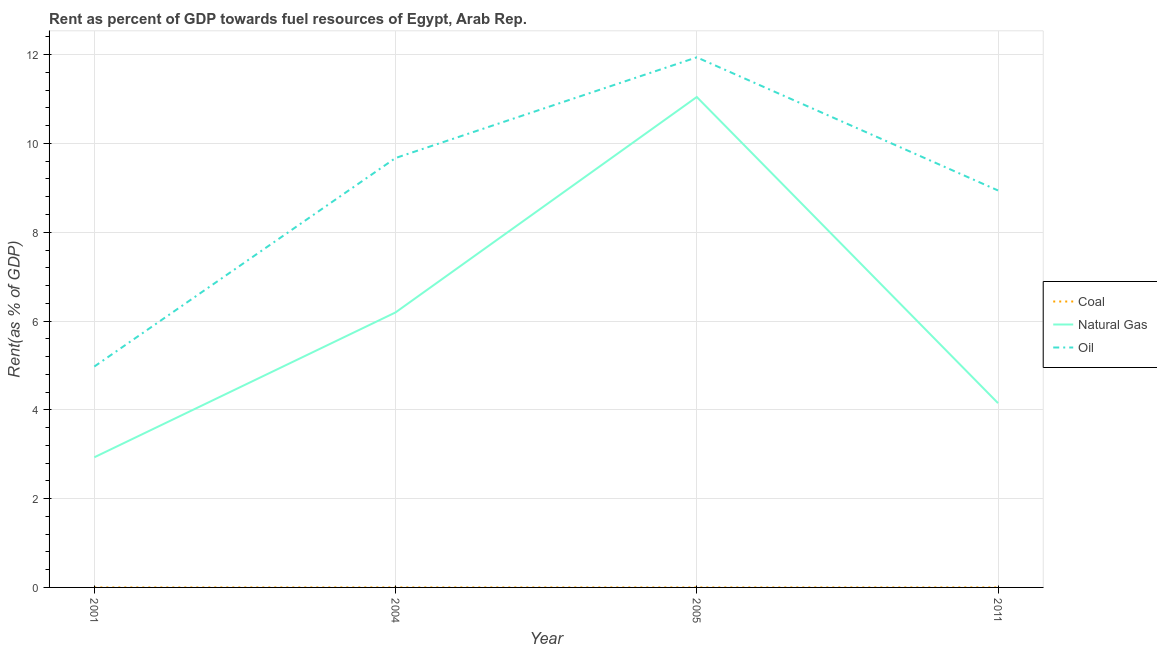How many different coloured lines are there?
Keep it short and to the point. 3. Does the line corresponding to rent towards coal intersect with the line corresponding to rent towards natural gas?
Your answer should be compact. No. Is the number of lines equal to the number of legend labels?
Make the answer very short. Yes. What is the rent towards oil in 2011?
Keep it short and to the point. 8.94. Across all years, what is the maximum rent towards oil?
Your response must be concise. 11.94. Across all years, what is the minimum rent towards coal?
Your answer should be compact. 1.02739128441411e-6. What is the total rent towards oil in the graph?
Offer a very short reply. 35.53. What is the difference between the rent towards natural gas in 2004 and that in 2005?
Make the answer very short. -4.85. What is the difference between the rent towards natural gas in 2005 and the rent towards coal in 2001?
Keep it short and to the point. 11.05. What is the average rent towards coal per year?
Ensure brevity in your answer.  0. In the year 2011, what is the difference between the rent towards natural gas and rent towards coal?
Your answer should be compact. 4.15. In how many years, is the rent towards natural gas greater than 2.8 %?
Make the answer very short. 4. What is the ratio of the rent towards natural gas in 2001 to that in 2005?
Your answer should be very brief. 0.27. Is the rent towards coal in 2004 less than that in 2005?
Your response must be concise. No. What is the difference between the highest and the second highest rent towards natural gas?
Offer a very short reply. 4.85. What is the difference between the highest and the lowest rent towards natural gas?
Provide a succinct answer. 8.12. Is the sum of the rent towards coal in 2001 and 2005 greater than the maximum rent towards oil across all years?
Provide a succinct answer. No. Is it the case that in every year, the sum of the rent towards coal and rent towards natural gas is greater than the rent towards oil?
Make the answer very short. No. Does the graph contain any zero values?
Ensure brevity in your answer.  No. Does the graph contain grids?
Offer a terse response. Yes. Where does the legend appear in the graph?
Give a very brief answer. Center right. How are the legend labels stacked?
Give a very brief answer. Vertical. What is the title of the graph?
Ensure brevity in your answer.  Rent as percent of GDP towards fuel resources of Egypt, Arab Rep. What is the label or title of the Y-axis?
Ensure brevity in your answer.  Rent(as % of GDP). What is the Rent(as % of GDP) of Coal in 2001?
Give a very brief answer. 1.02739128441411e-6. What is the Rent(as % of GDP) in Natural Gas in 2001?
Keep it short and to the point. 2.93. What is the Rent(as % of GDP) in Oil in 2001?
Give a very brief answer. 4.98. What is the Rent(as % of GDP) in Coal in 2004?
Give a very brief answer. 0. What is the Rent(as % of GDP) in Natural Gas in 2004?
Keep it short and to the point. 6.19. What is the Rent(as % of GDP) in Oil in 2004?
Offer a very short reply. 9.67. What is the Rent(as % of GDP) in Coal in 2005?
Ensure brevity in your answer.  0. What is the Rent(as % of GDP) of Natural Gas in 2005?
Make the answer very short. 11.05. What is the Rent(as % of GDP) of Oil in 2005?
Offer a terse response. 11.94. What is the Rent(as % of GDP) of Coal in 2011?
Provide a short and direct response. 0. What is the Rent(as % of GDP) of Natural Gas in 2011?
Offer a terse response. 4.15. What is the Rent(as % of GDP) in Oil in 2011?
Give a very brief answer. 8.94. Across all years, what is the maximum Rent(as % of GDP) of Coal?
Make the answer very short. 0. Across all years, what is the maximum Rent(as % of GDP) in Natural Gas?
Your answer should be compact. 11.05. Across all years, what is the maximum Rent(as % of GDP) of Oil?
Your response must be concise. 11.94. Across all years, what is the minimum Rent(as % of GDP) in Coal?
Provide a succinct answer. 1.02739128441411e-6. Across all years, what is the minimum Rent(as % of GDP) of Natural Gas?
Your answer should be very brief. 2.93. Across all years, what is the minimum Rent(as % of GDP) in Oil?
Offer a very short reply. 4.98. What is the total Rent(as % of GDP) in Coal in the graph?
Your answer should be compact. 0. What is the total Rent(as % of GDP) in Natural Gas in the graph?
Provide a succinct answer. 24.32. What is the total Rent(as % of GDP) of Oil in the graph?
Give a very brief answer. 35.53. What is the difference between the Rent(as % of GDP) of Coal in 2001 and that in 2004?
Your answer should be compact. -0. What is the difference between the Rent(as % of GDP) in Natural Gas in 2001 and that in 2004?
Your answer should be very brief. -3.26. What is the difference between the Rent(as % of GDP) in Oil in 2001 and that in 2004?
Your answer should be compact. -4.7. What is the difference between the Rent(as % of GDP) in Coal in 2001 and that in 2005?
Your response must be concise. -0. What is the difference between the Rent(as % of GDP) of Natural Gas in 2001 and that in 2005?
Ensure brevity in your answer.  -8.12. What is the difference between the Rent(as % of GDP) of Oil in 2001 and that in 2005?
Provide a succinct answer. -6.96. What is the difference between the Rent(as % of GDP) in Coal in 2001 and that in 2011?
Provide a short and direct response. -0. What is the difference between the Rent(as % of GDP) of Natural Gas in 2001 and that in 2011?
Your answer should be compact. -1.22. What is the difference between the Rent(as % of GDP) of Oil in 2001 and that in 2011?
Your answer should be compact. -3.97. What is the difference between the Rent(as % of GDP) of Coal in 2004 and that in 2005?
Your response must be concise. 0. What is the difference between the Rent(as % of GDP) in Natural Gas in 2004 and that in 2005?
Provide a succinct answer. -4.85. What is the difference between the Rent(as % of GDP) of Oil in 2004 and that in 2005?
Make the answer very short. -2.27. What is the difference between the Rent(as % of GDP) in Natural Gas in 2004 and that in 2011?
Offer a very short reply. 2.04. What is the difference between the Rent(as % of GDP) in Oil in 2004 and that in 2011?
Offer a very short reply. 0.73. What is the difference between the Rent(as % of GDP) in Coal in 2005 and that in 2011?
Your response must be concise. -0. What is the difference between the Rent(as % of GDP) in Natural Gas in 2005 and that in 2011?
Offer a terse response. 6.9. What is the difference between the Rent(as % of GDP) of Oil in 2005 and that in 2011?
Keep it short and to the point. 3. What is the difference between the Rent(as % of GDP) of Coal in 2001 and the Rent(as % of GDP) of Natural Gas in 2004?
Provide a short and direct response. -6.19. What is the difference between the Rent(as % of GDP) of Coal in 2001 and the Rent(as % of GDP) of Oil in 2004?
Ensure brevity in your answer.  -9.67. What is the difference between the Rent(as % of GDP) in Natural Gas in 2001 and the Rent(as % of GDP) in Oil in 2004?
Keep it short and to the point. -6.74. What is the difference between the Rent(as % of GDP) in Coal in 2001 and the Rent(as % of GDP) in Natural Gas in 2005?
Your answer should be very brief. -11.05. What is the difference between the Rent(as % of GDP) of Coal in 2001 and the Rent(as % of GDP) of Oil in 2005?
Your answer should be very brief. -11.94. What is the difference between the Rent(as % of GDP) in Natural Gas in 2001 and the Rent(as % of GDP) in Oil in 2005?
Your answer should be very brief. -9.01. What is the difference between the Rent(as % of GDP) of Coal in 2001 and the Rent(as % of GDP) of Natural Gas in 2011?
Ensure brevity in your answer.  -4.15. What is the difference between the Rent(as % of GDP) of Coal in 2001 and the Rent(as % of GDP) of Oil in 2011?
Your response must be concise. -8.94. What is the difference between the Rent(as % of GDP) in Natural Gas in 2001 and the Rent(as % of GDP) in Oil in 2011?
Offer a very short reply. -6.01. What is the difference between the Rent(as % of GDP) of Coal in 2004 and the Rent(as % of GDP) of Natural Gas in 2005?
Keep it short and to the point. -11.05. What is the difference between the Rent(as % of GDP) in Coal in 2004 and the Rent(as % of GDP) in Oil in 2005?
Offer a terse response. -11.94. What is the difference between the Rent(as % of GDP) in Natural Gas in 2004 and the Rent(as % of GDP) in Oil in 2005?
Keep it short and to the point. -5.75. What is the difference between the Rent(as % of GDP) of Coal in 2004 and the Rent(as % of GDP) of Natural Gas in 2011?
Your answer should be compact. -4.15. What is the difference between the Rent(as % of GDP) of Coal in 2004 and the Rent(as % of GDP) of Oil in 2011?
Offer a terse response. -8.94. What is the difference between the Rent(as % of GDP) in Natural Gas in 2004 and the Rent(as % of GDP) in Oil in 2011?
Your answer should be compact. -2.75. What is the difference between the Rent(as % of GDP) of Coal in 2005 and the Rent(as % of GDP) of Natural Gas in 2011?
Your response must be concise. -4.15. What is the difference between the Rent(as % of GDP) of Coal in 2005 and the Rent(as % of GDP) of Oil in 2011?
Ensure brevity in your answer.  -8.94. What is the difference between the Rent(as % of GDP) in Natural Gas in 2005 and the Rent(as % of GDP) in Oil in 2011?
Keep it short and to the point. 2.11. What is the average Rent(as % of GDP) of Natural Gas per year?
Offer a terse response. 6.08. What is the average Rent(as % of GDP) in Oil per year?
Give a very brief answer. 8.88. In the year 2001, what is the difference between the Rent(as % of GDP) in Coal and Rent(as % of GDP) in Natural Gas?
Offer a terse response. -2.93. In the year 2001, what is the difference between the Rent(as % of GDP) of Coal and Rent(as % of GDP) of Oil?
Your answer should be compact. -4.98. In the year 2001, what is the difference between the Rent(as % of GDP) in Natural Gas and Rent(as % of GDP) in Oil?
Keep it short and to the point. -2.04. In the year 2004, what is the difference between the Rent(as % of GDP) in Coal and Rent(as % of GDP) in Natural Gas?
Your response must be concise. -6.19. In the year 2004, what is the difference between the Rent(as % of GDP) of Coal and Rent(as % of GDP) of Oil?
Ensure brevity in your answer.  -9.67. In the year 2004, what is the difference between the Rent(as % of GDP) in Natural Gas and Rent(as % of GDP) in Oil?
Provide a succinct answer. -3.48. In the year 2005, what is the difference between the Rent(as % of GDP) of Coal and Rent(as % of GDP) of Natural Gas?
Provide a short and direct response. -11.05. In the year 2005, what is the difference between the Rent(as % of GDP) in Coal and Rent(as % of GDP) in Oil?
Provide a succinct answer. -11.94. In the year 2005, what is the difference between the Rent(as % of GDP) of Natural Gas and Rent(as % of GDP) of Oil?
Provide a short and direct response. -0.89. In the year 2011, what is the difference between the Rent(as % of GDP) of Coal and Rent(as % of GDP) of Natural Gas?
Ensure brevity in your answer.  -4.15. In the year 2011, what is the difference between the Rent(as % of GDP) in Coal and Rent(as % of GDP) in Oil?
Your response must be concise. -8.94. In the year 2011, what is the difference between the Rent(as % of GDP) of Natural Gas and Rent(as % of GDP) of Oil?
Your response must be concise. -4.79. What is the ratio of the Rent(as % of GDP) in Coal in 2001 to that in 2004?
Ensure brevity in your answer.  0. What is the ratio of the Rent(as % of GDP) of Natural Gas in 2001 to that in 2004?
Ensure brevity in your answer.  0.47. What is the ratio of the Rent(as % of GDP) in Oil in 2001 to that in 2004?
Offer a terse response. 0.51. What is the ratio of the Rent(as % of GDP) in Coal in 2001 to that in 2005?
Provide a short and direct response. 0. What is the ratio of the Rent(as % of GDP) of Natural Gas in 2001 to that in 2005?
Give a very brief answer. 0.27. What is the ratio of the Rent(as % of GDP) of Oil in 2001 to that in 2005?
Offer a terse response. 0.42. What is the ratio of the Rent(as % of GDP) in Coal in 2001 to that in 2011?
Offer a very short reply. 0. What is the ratio of the Rent(as % of GDP) of Natural Gas in 2001 to that in 2011?
Your response must be concise. 0.71. What is the ratio of the Rent(as % of GDP) of Oil in 2001 to that in 2011?
Make the answer very short. 0.56. What is the ratio of the Rent(as % of GDP) in Coal in 2004 to that in 2005?
Offer a very short reply. 2.83. What is the ratio of the Rent(as % of GDP) of Natural Gas in 2004 to that in 2005?
Offer a terse response. 0.56. What is the ratio of the Rent(as % of GDP) of Oil in 2004 to that in 2005?
Offer a terse response. 0.81. What is the ratio of the Rent(as % of GDP) in Coal in 2004 to that in 2011?
Offer a terse response. 1.13. What is the ratio of the Rent(as % of GDP) of Natural Gas in 2004 to that in 2011?
Your answer should be compact. 1.49. What is the ratio of the Rent(as % of GDP) in Oil in 2004 to that in 2011?
Provide a succinct answer. 1.08. What is the ratio of the Rent(as % of GDP) of Coal in 2005 to that in 2011?
Your answer should be compact. 0.4. What is the ratio of the Rent(as % of GDP) of Natural Gas in 2005 to that in 2011?
Keep it short and to the point. 2.66. What is the ratio of the Rent(as % of GDP) of Oil in 2005 to that in 2011?
Give a very brief answer. 1.34. What is the difference between the highest and the second highest Rent(as % of GDP) of Coal?
Ensure brevity in your answer.  0. What is the difference between the highest and the second highest Rent(as % of GDP) in Natural Gas?
Offer a terse response. 4.85. What is the difference between the highest and the second highest Rent(as % of GDP) of Oil?
Your response must be concise. 2.27. What is the difference between the highest and the lowest Rent(as % of GDP) of Coal?
Make the answer very short. 0. What is the difference between the highest and the lowest Rent(as % of GDP) of Natural Gas?
Provide a succinct answer. 8.12. What is the difference between the highest and the lowest Rent(as % of GDP) of Oil?
Give a very brief answer. 6.96. 